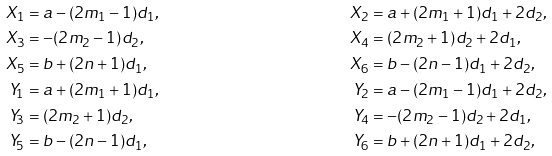<formula> <loc_0><loc_0><loc_500><loc_500>X _ { 1 } & = a - ( 2 m _ { 1 } - 1 ) d _ { 1 } , & X _ { 2 } & = a + ( 2 m _ { 1 } + 1 ) d _ { 1 } + 2 d _ { 2 } , \\ X _ { 3 } & = - ( 2 m _ { 2 } - 1 ) d _ { 2 } , & X _ { 4 } & = ( 2 m _ { 2 } + 1 ) d _ { 2 } + 2 d _ { 1 } , \\ X _ { 5 } & = b + ( 2 n + 1 ) d _ { 1 } , & X _ { 6 } & = b - ( 2 n - 1 ) d _ { 1 } + 2 d _ { 2 } , \\ Y _ { 1 } & = a + ( 2 m _ { 1 } + 1 ) d _ { 1 } , & Y _ { 2 } & = a - ( 2 m _ { 1 } - 1 ) d _ { 1 } + 2 d _ { 2 } , \\ Y _ { 3 } & = ( 2 m _ { 2 } + 1 ) d _ { 2 } , & Y _ { 4 } & = - ( 2 m _ { 2 } - 1 ) d _ { 2 } + 2 d _ { 1 } , \\ Y _ { 5 } & = b - ( 2 n - 1 ) d _ { 1 } , & Y _ { 6 } & = b + ( 2 n + 1 ) d _ { 1 } + 2 d _ { 2 } ,</formula> 